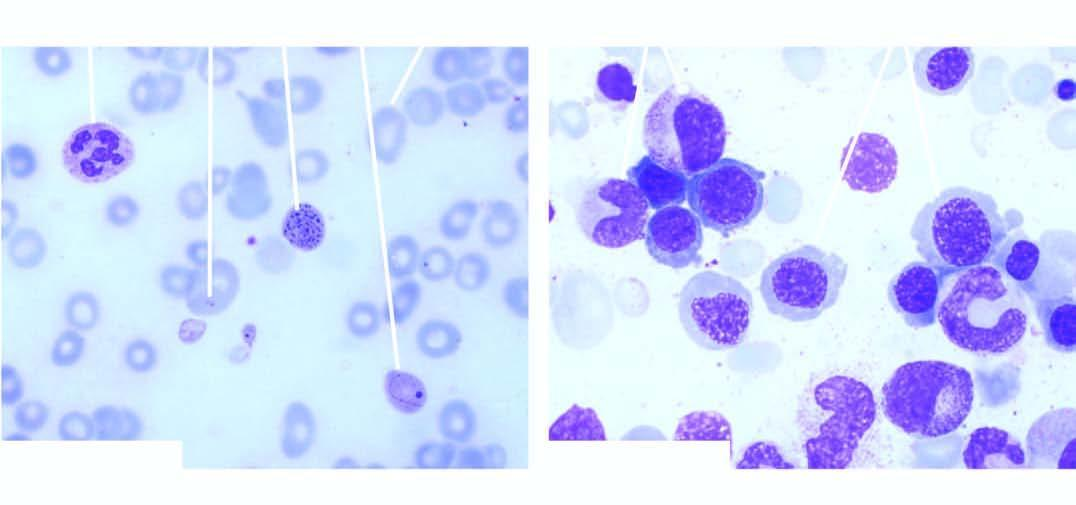does examination of bone marrow aspirate show megaloblastic erythropoiesis?
Answer the question using a single word or phrase. Yes 